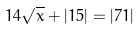Convert formula to latex. <formula><loc_0><loc_0><loc_500><loc_500>1 4 \sqrt { x } + | 1 5 | = | 7 1 |</formula> 